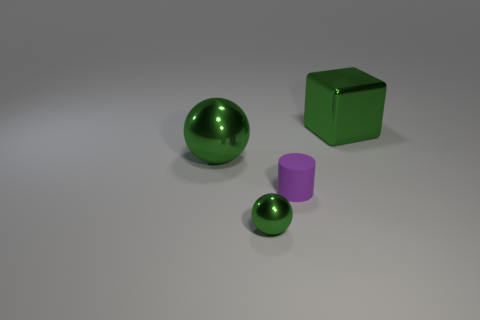Add 2 purple rubber objects. How many objects exist? 6 Subtract all blocks. How many objects are left? 3 Subtract 0 yellow cubes. How many objects are left? 4 Subtract all small purple cylinders. Subtract all big metal cubes. How many objects are left? 2 Add 4 green cubes. How many green cubes are left? 5 Add 4 red blocks. How many red blocks exist? 4 